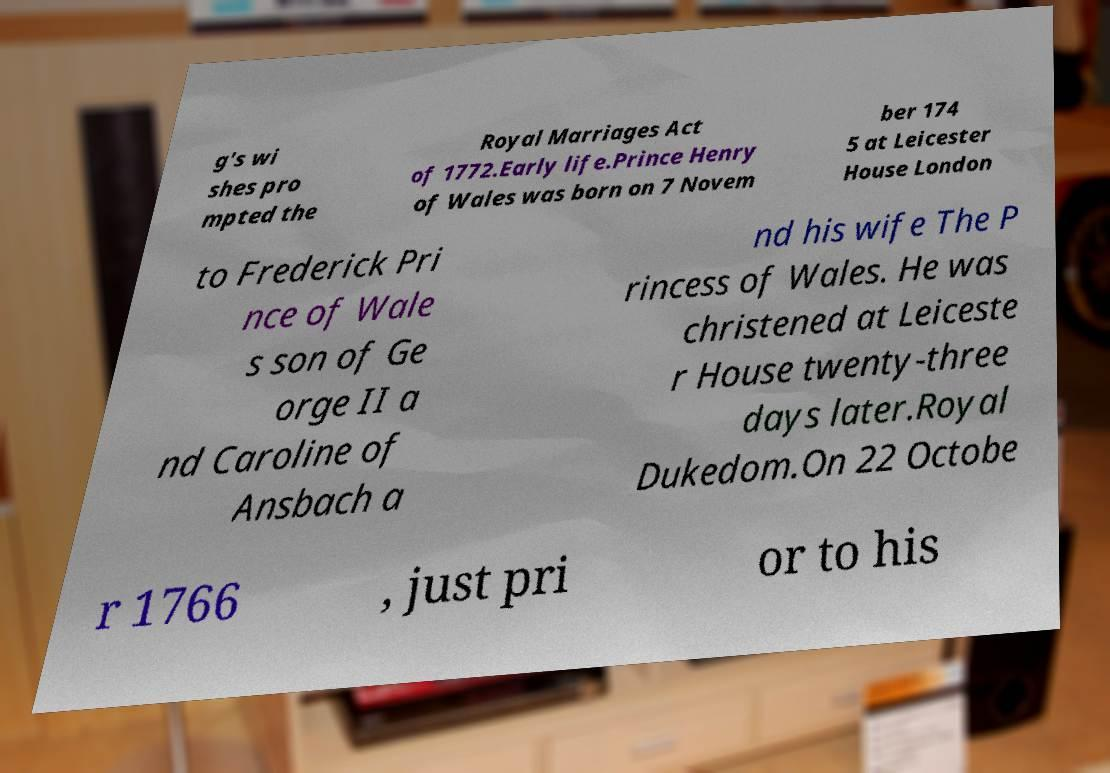Could you assist in decoding the text presented in this image and type it out clearly? g's wi shes pro mpted the Royal Marriages Act of 1772.Early life.Prince Henry of Wales was born on 7 Novem ber 174 5 at Leicester House London to Frederick Pri nce of Wale s son of Ge orge II a nd Caroline of Ansbach a nd his wife The P rincess of Wales. He was christened at Leiceste r House twenty-three days later.Royal Dukedom.On 22 Octobe r 1766 , just pri or to his 